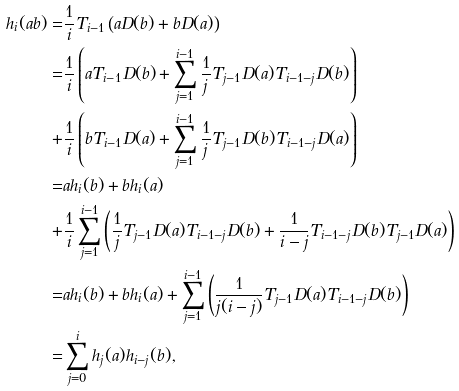Convert formula to latex. <formula><loc_0><loc_0><loc_500><loc_500>h _ { i } ( a b ) = & \frac { 1 } { i } T _ { i - 1 } \left ( a D ( b ) + b D ( a ) \right ) \\ = & \frac { 1 } { i } \left ( a T _ { i - 1 } D ( b ) + \sum _ { j = 1 } ^ { i - 1 } \frac { 1 } { j } T _ { j - 1 } D ( a ) T _ { i - 1 - j } D ( b ) \right ) \\ + & \frac { 1 } { i } \left ( b T _ { i - 1 } D ( a ) + \sum _ { j = 1 } ^ { i - 1 } \frac { 1 } { j } T _ { j - 1 } D ( b ) T _ { i - 1 - j } D ( a ) \right ) \\ = & a h _ { i } ( b ) + b h _ { i } ( a ) \\ + & \frac { 1 } { i } \sum _ { j = 1 } ^ { i - 1 } \left ( \frac { 1 } { j } T _ { j - 1 } D ( a ) T _ { i - 1 - j } D ( b ) + \frac { 1 } { i - j } T _ { i - 1 - j } D ( b ) T _ { j - 1 } D ( a ) \right ) \\ = & a h _ { i } ( b ) + b h _ { i } ( a ) + \sum _ { j = 1 } ^ { i - 1 } \left ( \frac { 1 } { j ( i - j ) } T _ { j - 1 } D ( a ) T _ { i - 1 - j } D ( b ) \right ) \\ = & \sum _ { j = 0 } ^ { i } h _ { j } ( a ) h _ { i - j } ( b ) ,</formula> 